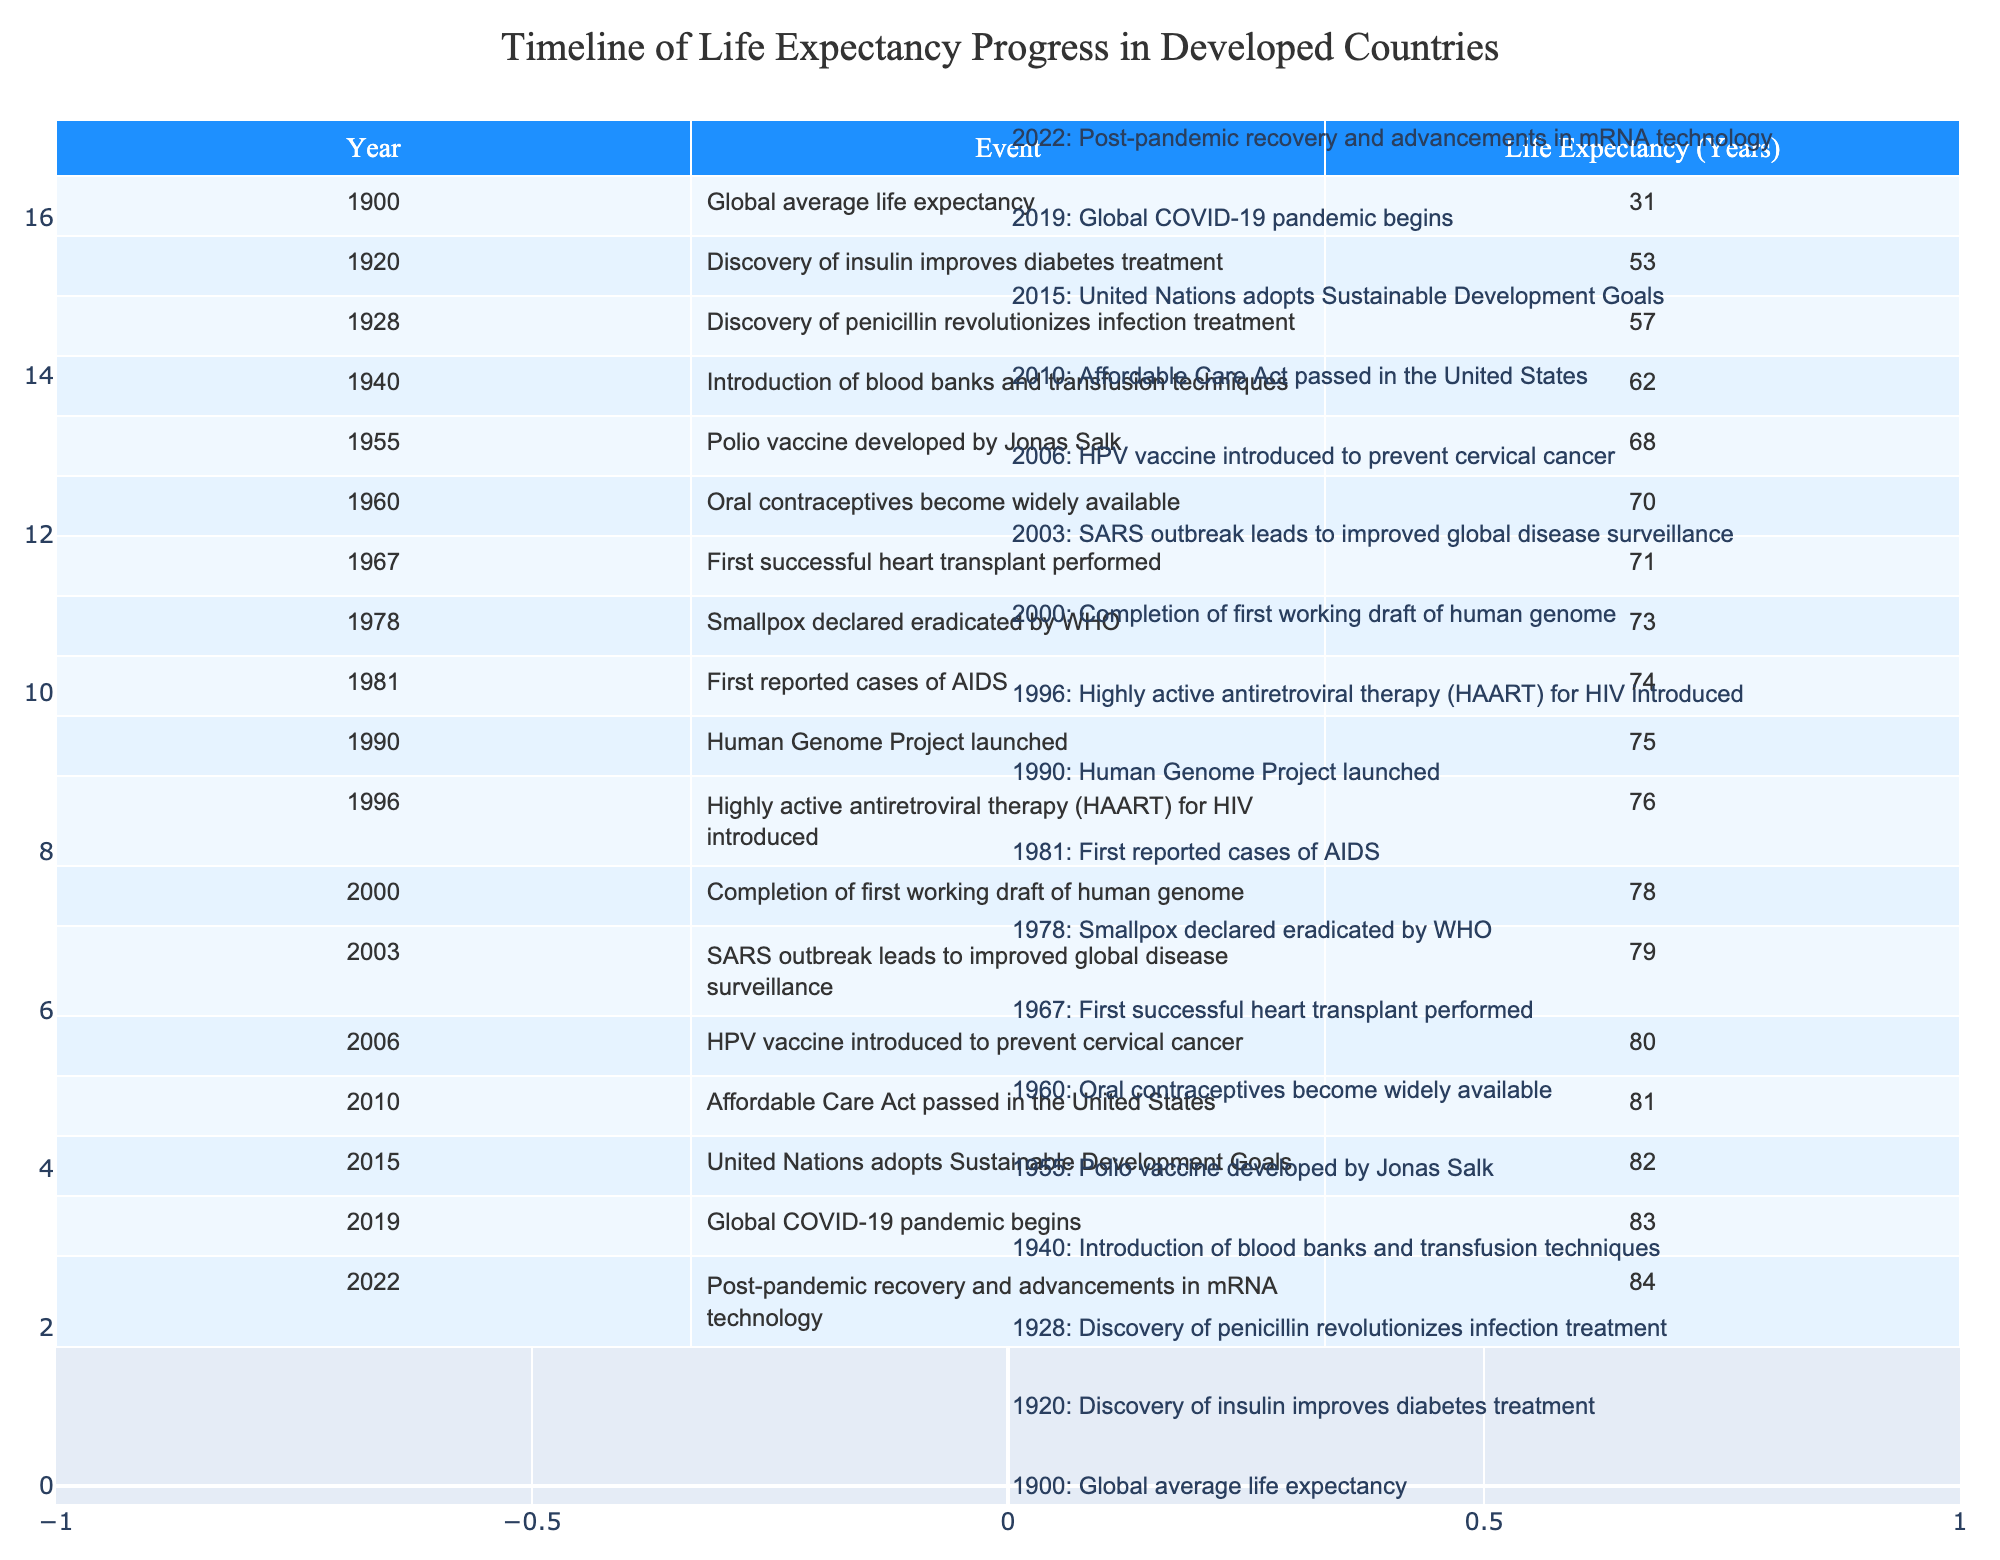What was the life expectancy in 1900? The table shows that the life expectancy in the year 1900 was 31 years. This is retrieved directly from the corresponding row in the table.
Answer: 31 What significant medical event occurred in 1940, and what was the life expectancy then? According to the table, in 1940, the event noted is the introduction of blood banks and transfusion techniques, and the life expectancy at that time was 62 years. These details can be found in that specific entry in the table.
Answer: Blood banks introduced; 62 years How many years did life expectancy increase from 1920 to 2003? The life expectancy in 1920 was 53 years, and in 2003 it was 79 years. To find the increase, we subtract 53 from 79, resulting in an increase of 26 years (79 - 53 = 26).
Answer: 26 Was the life expectancy higher in 1967 compared to 1981? From the table, the life expectancy in 1967 was 71 years while in 1981 it was 74 years. Since 74 is greater than 71, the statement is true.
Answer: Yes What event coincided with the highest life expectancy recorded in the table and what was that life expectancy? The highest life expectancy recorded in the table is 84 years, which occurred in 2022 after advancements in mRNA technology post-pandemic. This information is referenced from the last entry in the table.
Answer: 2022; 84 years 